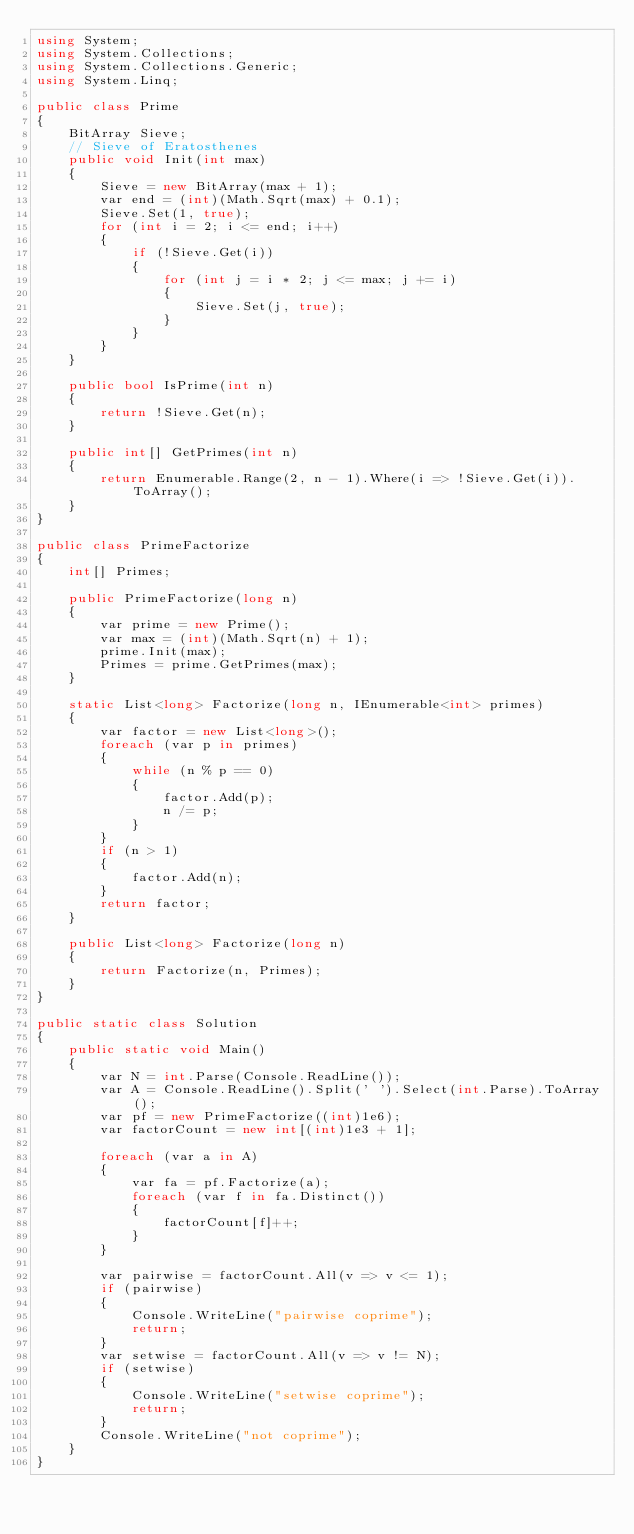Convert code to text. <code><loc_0><loc_0><loc_500><loc_500><_C#_>using System;
using System.Collections;
using System.Collections.Generic;
using System.Linq;

public class Prime
{
    BitArray Sieve;
    // Sieve of Eratosthenes
    public void Init(int max)
    {
        Sieve = new BitArray(max + 1);
        var end = (int)(Math.Sqrt(max) + 0.1);
        Sieve.Set(1, true);
        for (int i = 2; i <= end; i++)
        {
            if (!Sieve.Get(i))
            {
                for (int j = i * 2; j <= max; j += i)
                {
                    Sieve.Set(j, true);
                }
            }
        }
    }

    public bool IsPrime(int n)
    {
        return !Sieve.Get(n);
    }

    public int[] GetPrimes(int n)
    {
        return Enumerable.Range(2, n - 1).Where(i => !Sieve.Get(i)).ToArray();
    }
}

public class PrimeFactorize
{
    int[] Primes;

    public PrimeFactorize(long n)
    {
        var prime = new Prime();
        var max = (int)(Math.Sqrt(n) + 1);
        prime.Init(max);
        Primes = prime.GetPrimes(max);
    }

    static List<long> Factorize(long n, IEnumerable<int> primes)
    {
        var factor = new List<long>();
        foreach (var p in primes)
        {
            while (n % p == 0)
            {
                factor.Add(p);
                n /= p;
            }
        }
        if (n > 1)
        {
            factor.Add(n);
        }
        return factor;
    }

    public List<long> Factorize(long n)
    {
        return Factorize(n, Primes);
    }
}

public static class Solution
{
    public static void Main()
    {
        var N = int.Parse(Console.ReadLine());
        var A = Console.ReadLine().Split(' ').Select(int.Parse).ToArray();
        var pf = new PrimeFactorize((int)1e6);
        var factorCount = new int[(int)1e3 + 1];

        foreach (var a in A)
        {
            var fa = pf.Factorize(a);
            foreach (var f in fa.Distinct())
            {
                factorCount[f]++;
            }
        }

        var pairwise = factorCount.All(v => v <= 1);
        if (pairwise)
        {
            Console.WriteLine("pairwise coprime");
            return;
        }
        var setwise = factorCount.All(v => v != N);
        if (setwise)
        {
            Console.WriteLine("setwise coprime");
            return;
        }
        Console.WriteLine("not coprime");
    }
}</code> 